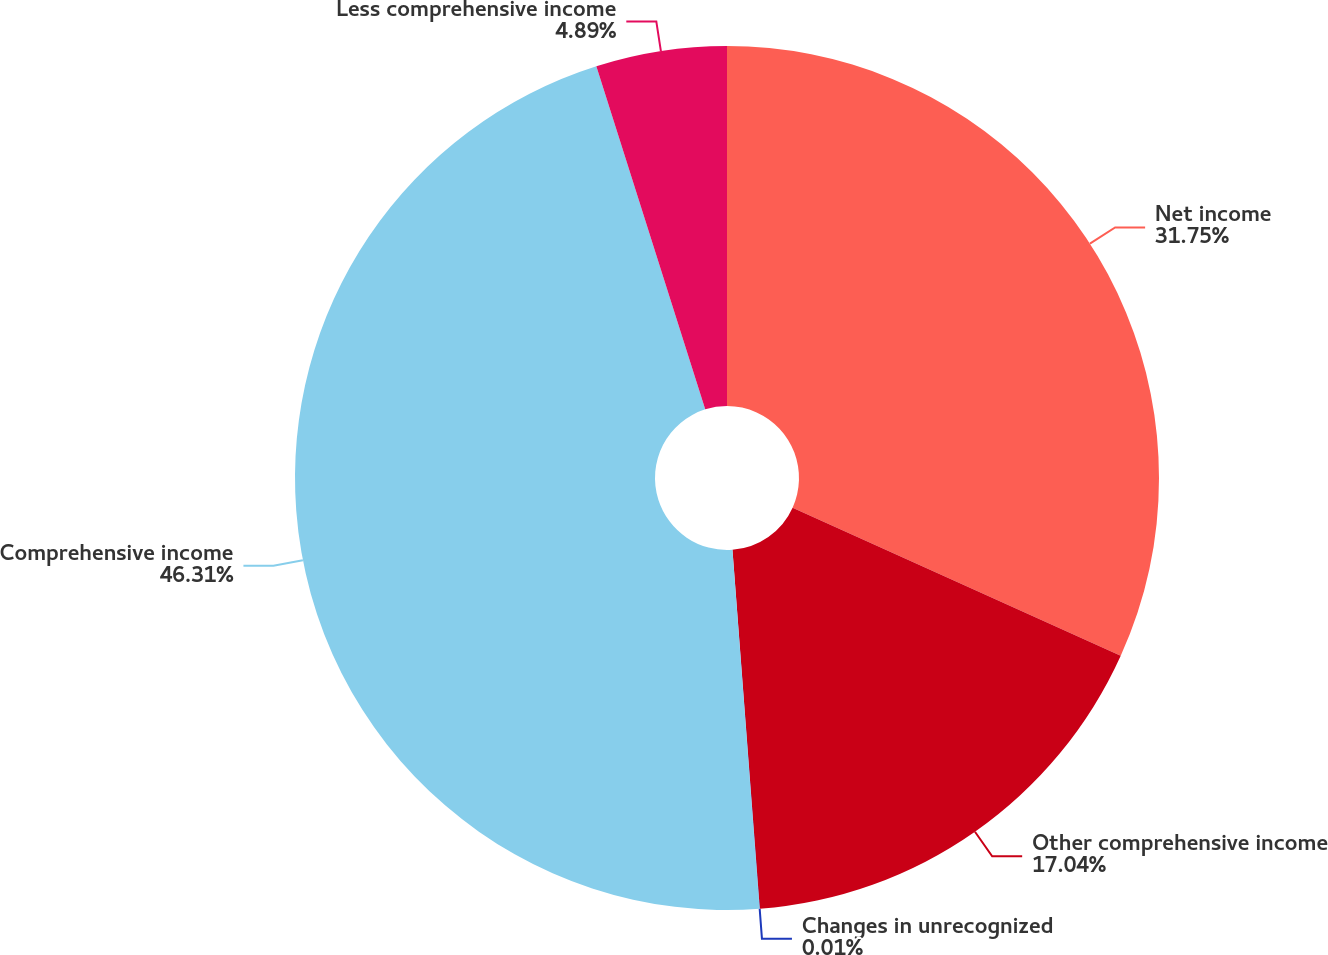Convert chart. <chart><loc_0><loc_0><loc_500><loc_500><pie_chart><fcel>Net income<fcel>Other comprehensive income<fcel>Changes in unrecognized<fcel>Comprehensive income<fcel>Less comprehensive income<nl><fcel>31.75%<fcel>17.04%<fcel>0.01%<fcel>46.31%<fcel>4.89%<nl></chart> 